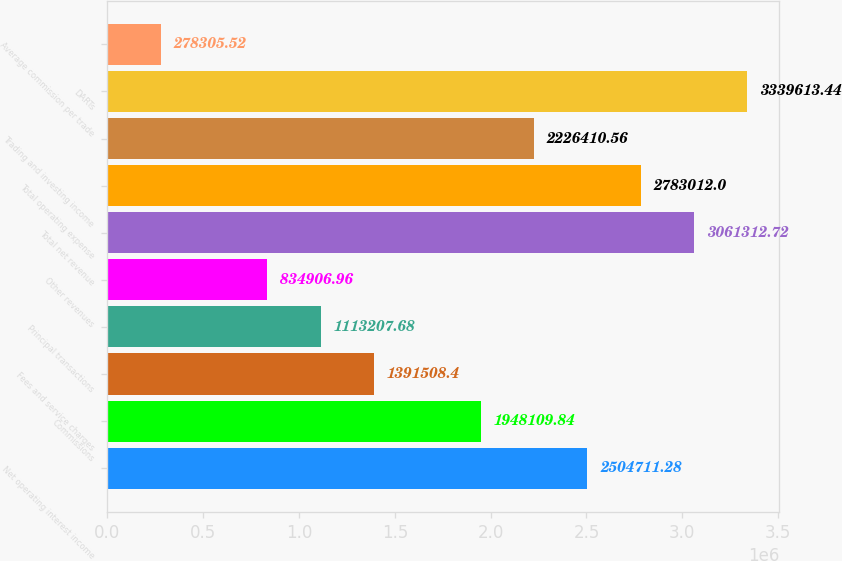<chart> <loc_0><loc_0><loc_500><loc_500><bar_chart><fcel>Net operating interest income<fcel>Commissions<fcel>Fees and service charges<fcel>Principal transactions<fcel>Other revenues<fcel>Total net revenue<fcel>Total operating expense<fcel>Trading and investing income<fcel>DARTs<fcel>Average commission per trade<nl><fcel>2.50471e+06<fcel>1.94811e+06<fcel>1.39151e+06<fcel>1.11321e+06<fcel>834907<fcel>3.06131e+06<fcel>2.78301e+06<fcel>2.22641e+06<fcel>3.33961e+06<fcel>278306<nl></chart> 